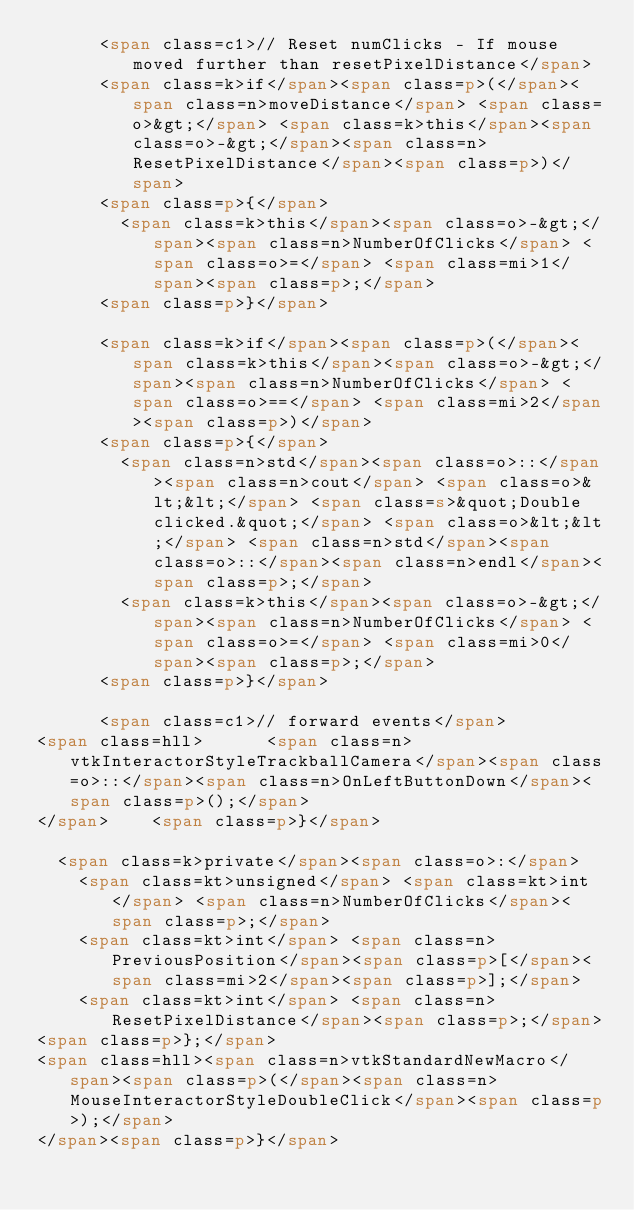Convert code to text. <code><loc_0><loc_0><loc_500><loc_500><_HTML_>      <span class=c1>// Reset numClicks - If mouse moved further than resetPixelDistance</span>
      <span class=k>if</span><span class=p>(</span><span class=n>moveDistance</span> <span class=o>&gt;</span> <span class=k>this</span><span class=o>-&gt;</span><span class=n>ResetPixelDistance</span><span class=p>)</span>
      <span class=p>{</span>
        <span class=k>this</span><span class=o>-&gt;</span><span class=n>NumberOfClicks</span> <span class=o>=</span> <span class=mi>1</span><span class=p>;</span>
      <span class=p>}</span>

      <span class=k>if</span><span class=p>(</span><span class=k>this</span><span class=o>-&gt;</span><span class=n>NumberOfClicks</span> <span class=o>==</span> <span class=mi>2</span><span class=p>)</span>
      <span class=p>{</span>
        <span class=n>std</span><span class=o>::</span><span class=n>cout</span> <span class=o>&lt;&lt;</span> <span class=s>&quot;Double clicked.&quot;</span> <span class=o>&lt;&lt;</span> <span class=n>std</span><span class=o>::</span><span class=n>endl</span><span class=p>;</span>
        <span class=k>this</span><span class=o>-&gt;</span><span class=n>NumberOfClicks</span> <span class=o>=</span> <span class=mi>0</span><span class=p>;</span>
      <span class=p>}</span>

      <span class=c1>// forward events</span>
<span class=hll>      <span class=n>vtkInteractorStyleTrackballCamera</span><span class=o>::</span><span class=n>OnLeftButtonDown</span><span class=p>();</span>
</span>    <span class=p>}</span>

  <span class=k>private</span><span class=o>:</span>
    <span class=kt>unsigned</span> <span class=kt>int</span> <span class=n>NumberOfClicks</span><span class=p>;</span>
    <span class=kt>int</span> <span class=n>PreviousPosition</span><span class=p>[</span><span class=mi>2</span><span class=p>];</span>
    <span class=kt>int</span> <span class=n>ResetPixelDistance</span><span class=p>;</span>
<span class=p>};</span>
<span class=hll><span class=n>vtkStandardNewMacro</span><span class=p>(</span><span class=n>MouseInteractorStyleDoubleClick</span><span class=p>);</span>
</span><span class=p>}</span>
</code> 